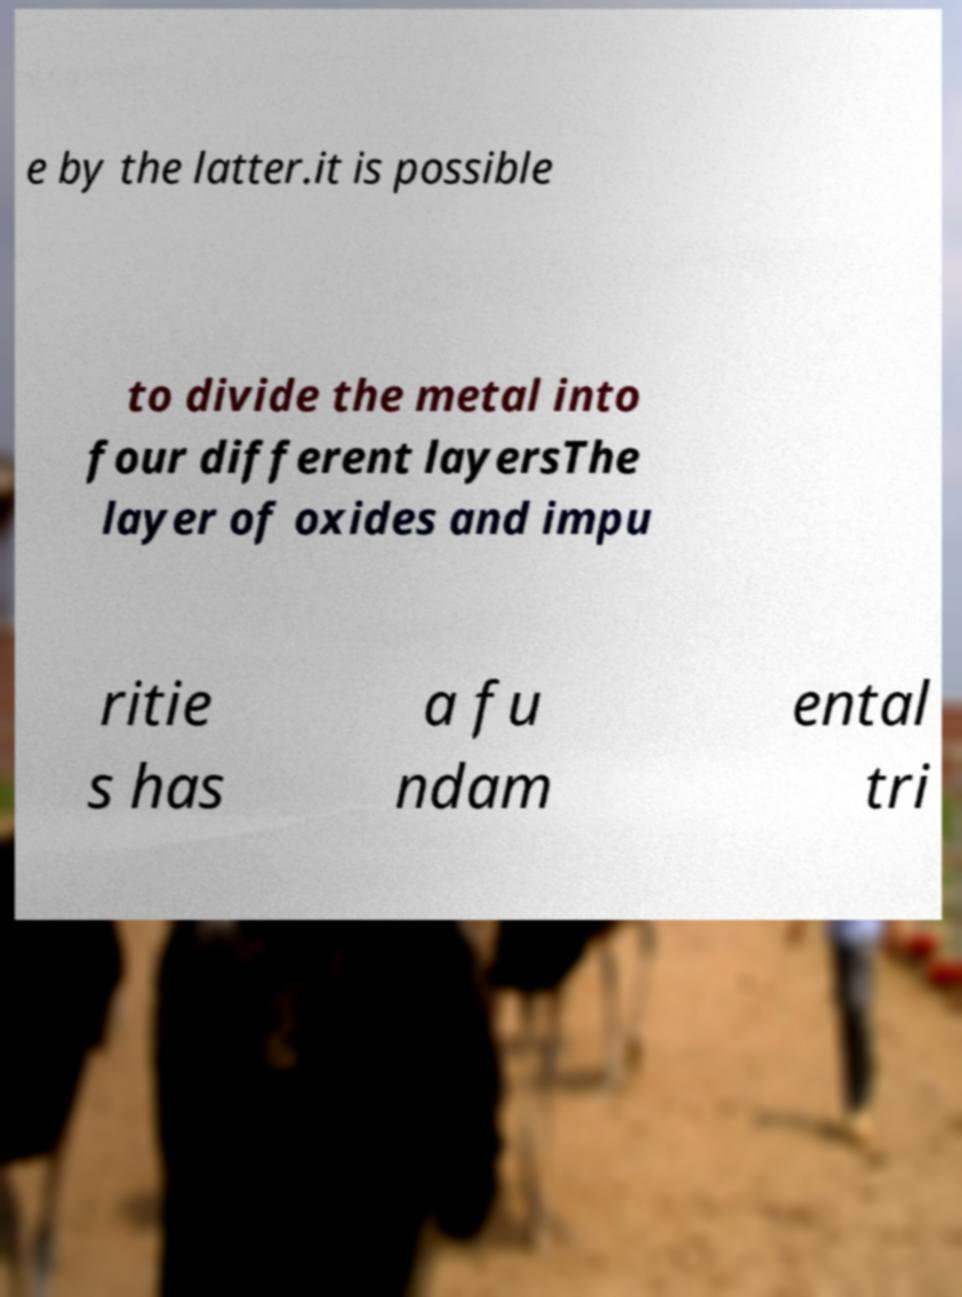Could you extract and type out the text from this image? e by the latter.it is possible to divide the metal into four different layersThe layer of oxides and impu ritie s has a fu ndam ental tri 